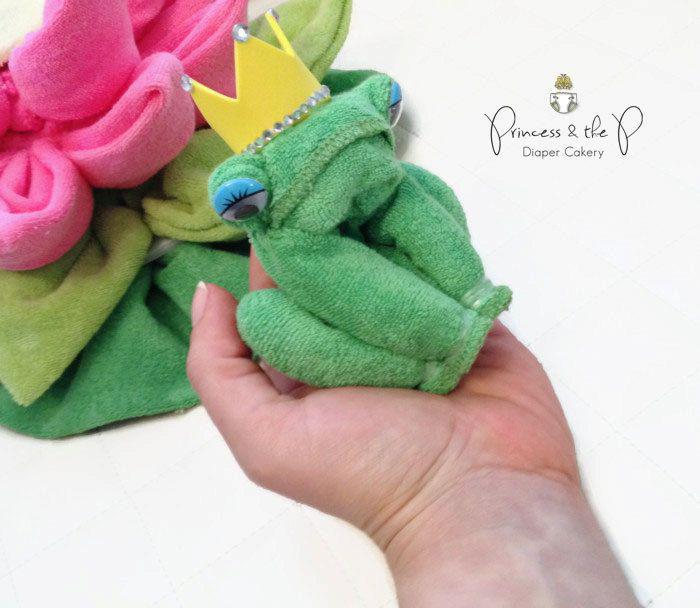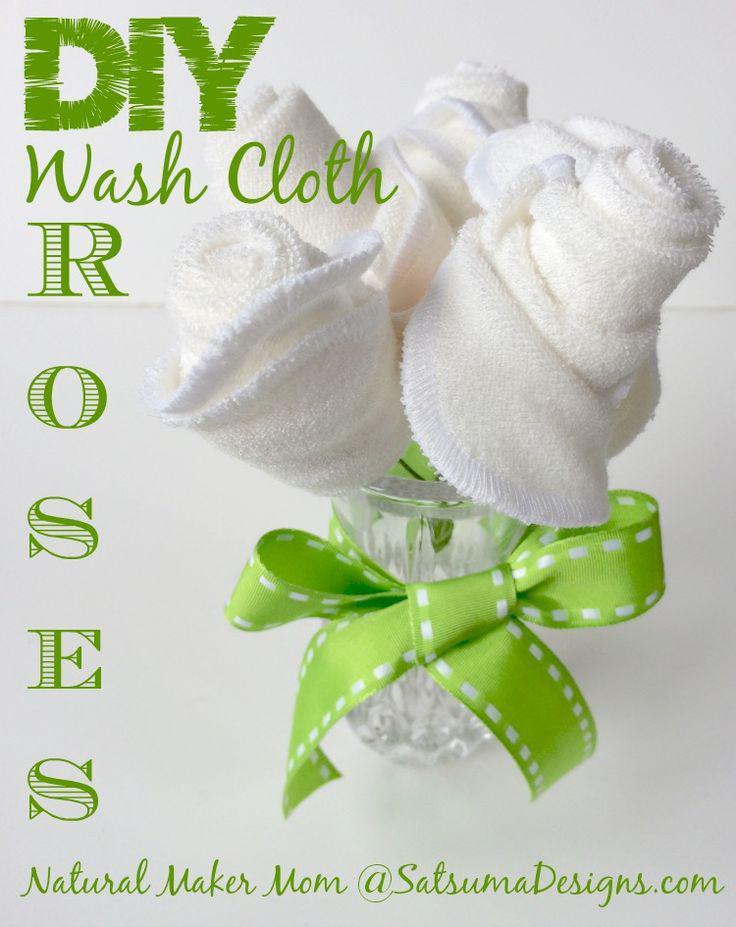The first image is the image on the left, the second image is the image on the right. Evaluate the accuracy of this statement regarding the images: "In the right image, there is a white towel with a white and yellow striped strip of ribbon". Is it true? Answer yes or no. No. The first image is the image on the left, the second image is the image on the right. Considering the images on both sides, is "There is a white towel with a yellow and white band down the center in the image on the right." valid? Answer yes or no. No. 